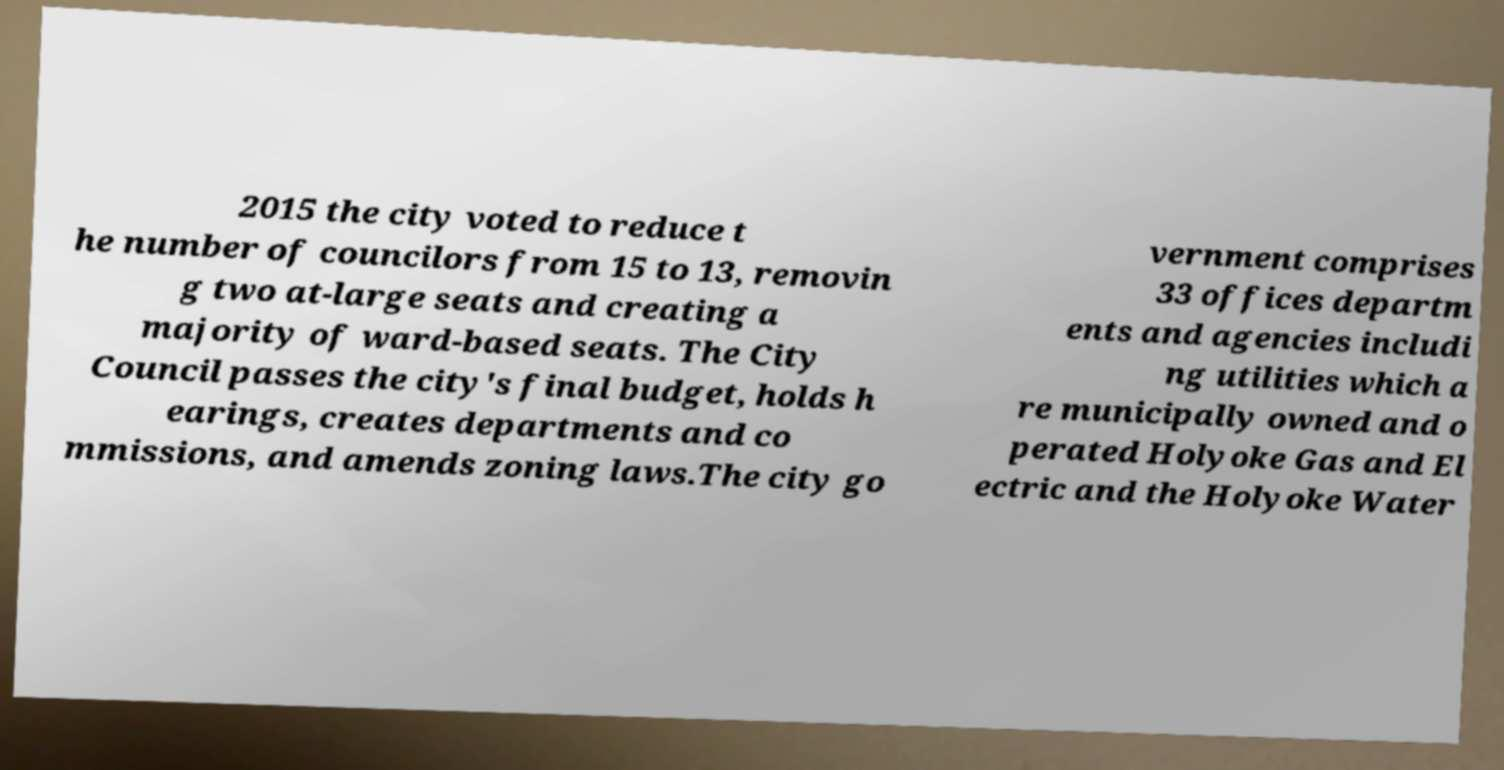For documentation purposes, I need the text within this image transcribed. Could you provide that? 2015 the city voted to reduce t he number of councilors from 15 to 13, removin g two at-large seats and creating a majority of ward-based seats. The City Council passes the city's final budget, holds h earings, creates departments and co mmissions, and amends zoning laws.The city go vernment comprises 33 offices departm ents and agencies includi ng utilities which a re municipally owned and o perated Holyoke Gas and El ectric and the Holyoke Water 